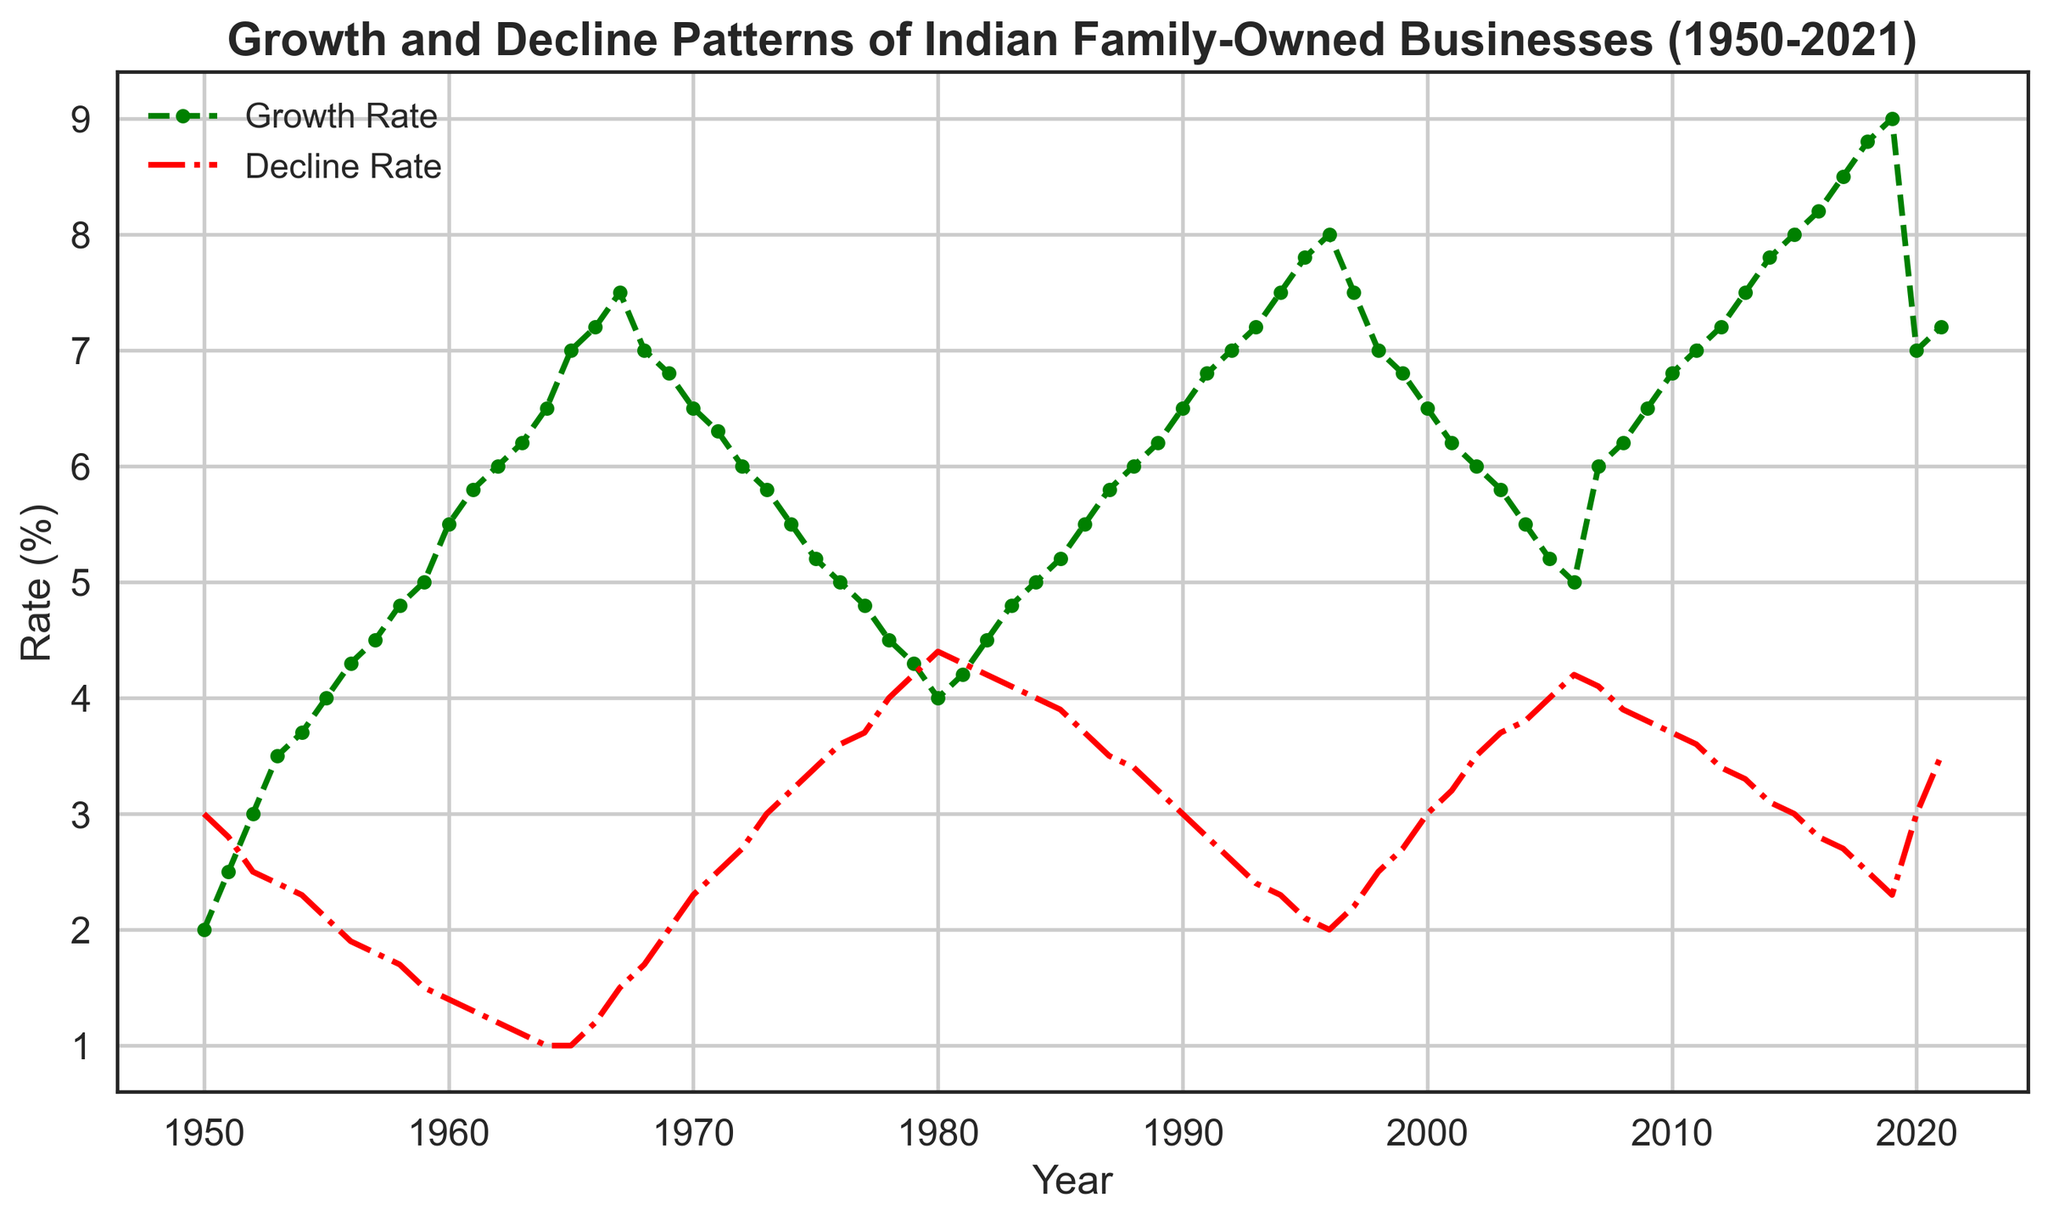What are the highest Growth Rates and Decline Rates observed during the period 1950-2021? Looking at the figure, the highest Growth Rate is in 2019 with a value of 9%, and the highest Decline Rate is in 1950 with a value of 3.7%.
Answer: Growth: 9%, Decline: 3.7% In which year did the Growth Rate first exceed 6%? The Growth Rate exceeded 6% for the first time in 1964, where it reached 6.5%.
Answer: 1964 Between 1974 and 1984, did the Growth Rate ever fall below 4%? According to the figure, the Growth Rate did not fall below 4% between 1974 and 1984. It hovered around 4.0-5.2% during this period.
Answer: No What was the difference between the Growth Rate and Decline Rate in 2020? In 2020, the Growth Rate was 7% and the Decline Rate was 3%. The difference is 7% - 3% = 4%.
Answer: 4% Compare the Growth Rate trend to the Decline Rate trend from 1995 to 2005. The Growth Rate remained relatively stable around 6.5% to 8% from 1995 to 2005, whereas the Decline Rate saw a fluctuating decline from 2% to 4.2%.
Answer: Growth: Stable, Decline: Fluctuating In which year between 1950 and 1960 did the Decline Rate reach its lowest value? The Decline Rate reached its lowest value in 1960 with a value of 1.4% during the 1950-1960 period.
Answer: 1960 Calculate the average Growth Rate from 1980 to 1990. The Growth Rates for the years 1980 to 1990 are 4, 4.2, 4.5, 4.8, 5, 5.2, 5.5, 5.8, 6, and 6.2 respectively. Sum = 52.2. Average = 52.2 / 10 = 5.22%.
Answer: 5.22% What is the visual relationship between the two rate trends from 1950 to 1970? Visually, the Growth Rate shows an increasing trend while the Decline Rate shows a decreasing trend from 1950 to 1970. The colors used are green (Growth Rate) and red (Decline Rate).
Answer: Growth: Increasing, Decline: Decreasing In which decade did the Decline Rate display the most stability? The Decline Rate remained quite stable during the decade of 1960-1969, staying around 1-2%.
Answer: 1960s Did the Growth Rate exceed the Decline Rate in every year during the period 1950-2021? No, during 1950-1952, the Decline Rate was higher than the Growth Rate. After 1952, the Growth Rate consistently exceeded the Decline Rate.
Answer: No 